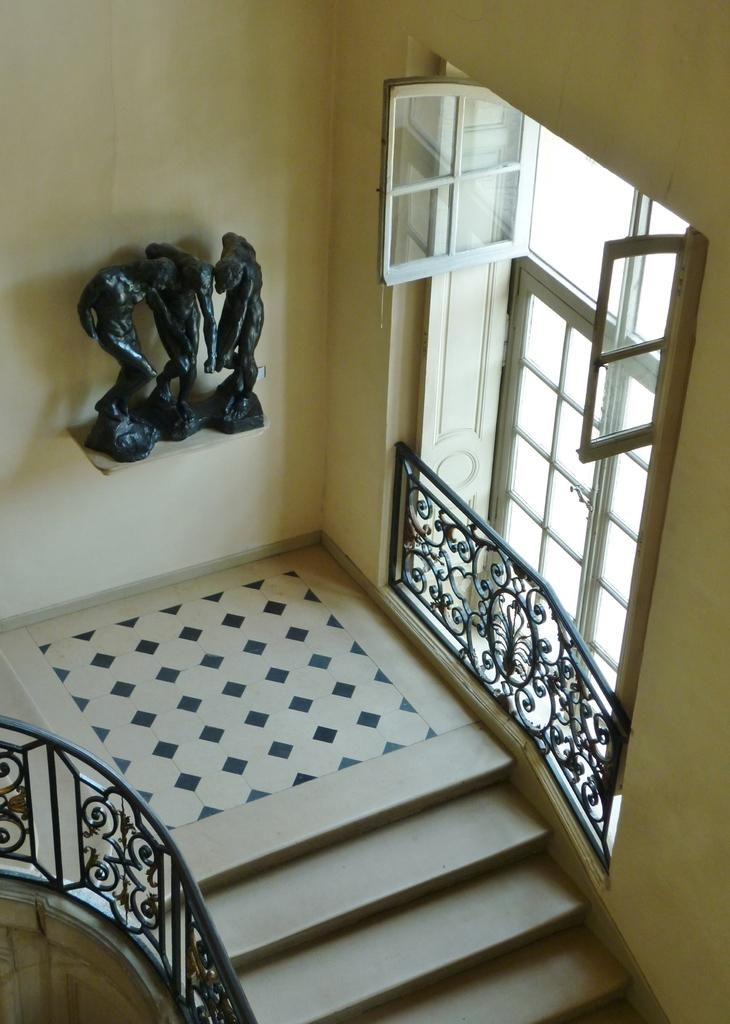What type of structure can be seen in the image? There are stairs in the image. What material are the railings made of? The railings in the image are made of iron. What architectural feature is visible on the wall? There are windows on the wall in the image. What type of decoration is present on the wall? There are human statues on the wall stand in the image. How many zippers can be seen on the human statues in the image? There are no zippers present on the human statues in the image. What type of spot is visible on the stairs in the image? There is no spot visible on the stairs in the image. 